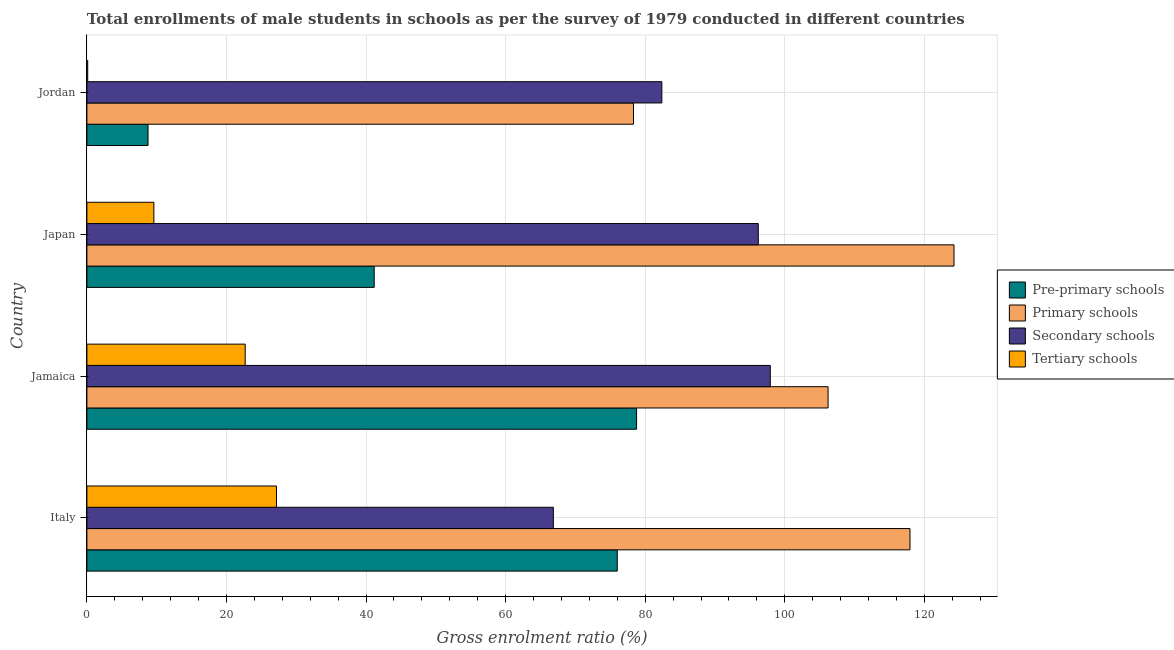How many groups of bars are there?
Your answer should be very brief. 4. Are the number of bars on each tick of the Y-axis equal?
Your response must be concise. Yes. How many bars are there on the 2nd tick from the bottom?
Give a very brief answer. 4. What is the label of the 1st group of bars from the top?
Your answer should be compact. Jordan. What is the gross enrolment ratio(male) in pre-primary schools in Jamaica?
Your answer should be compact. 78.76. Across all countries, what is the maximum gross enrolment ratio(male) in primary schools?
Keep it short and to the point. 124.24. Across all countries, what is the minimum gross enrolment ratio(male) in pre-primary schools?
Your answer should be very brief. 8.76. In which country was the gross enrolment ratio(male) in secondary schools minimum?
Your answer should be very brief. Italy. What is the total gross enrolment ratio(male) in tertiary schools in the graph?
Give a very brief answer. 59.56. What is the difference between the gross enrolment ratio(male) in tertiary schools in Japan and that in Jordan?
Provide a short and direct response. 9.48. What is the difference between the gross enrolment ratio(male) in pre-primary schools in Japan and the gross enrolment ratio(male) in primary schools in Italy?
Offer a terse response. -76.77. What is the average gross enrolment ratio(male) in primary schools per country?
Keep it short and to the point. 106.67. What is the difference between the gross enrolment ratio(male) in secondary schools and gross enrolment ratio(male) in primary schools in Jamaica?
Your answer should be very brief. -8.28. In how many countries, is the gross enrolment ratio(male) in primary schools greater than 48 %?
Provide a short and direct response. 4. What is the ratio of the gross enrolment ratio(male) in primary schools in Italy to that in Jamaica?
Your answer should be compact. 1.11. Is the difference between the gross enrolment ratio(male) in tertiary schools in Italy and Jordan greater than the difference between the gross enrolment ratio(male) in primary schools in Italy and Jordan?
Ensure brevity in your answer.  No. What is the difference between the highest and the second highest gross enrolment ratio(male) in tertiary schools?
Make the answer very short. 4.49. What is the difference between the highest and the lowest gross enrolment ratio(male) in secondary schools?
Give a very brief answer. 31.08. What does the 1st bar from the top in Jamaica represents?
Provide a short and direct response. Tertiary schools. What does the 3rd bar from the bottom in Jamaica represents?
Your answer should be very brief. Secondary schools. Is it the case that in every country, the sum of the gross enrolment ratio(male) in pre-primary schools and gross enrolment ratio(male) in primary schools is greater than the gross enrolment ratio(male) in secondary schools?
Give a very brief answer. Yes. How many countries are there in the graph?
Offer a very short reply. 4. Are the values on the major ticks of X-axis written in scientific E-notation?
Make the answer very short. No. Where does the legend appear in the graph?
Give a very brief answer. Center right. How are the legend labels stacked?
Provide a short and direct response. Vertical. What is the title of the graph?
Your answer should be very brief. Total enrollments of male students in schools as per the survey of 1979 conducted in different countries. Does "Belgium" appear as one of the legend labels in the graph?
Keep it short and to the point. No. What is the label or title of the X-axis?
Make the answer very short. Gross enrolment ratio (%). What is the Gross enrolment ratio (%) in Pre-primary schools in Italy?
Your answer should be very brief. 75.99. What is the Gross enrolment ratio (%) in Primary schools in Italy?
Make the answer very short. 117.93. What is the Gross enrolment ratio (%) of Secondary schools in Italy?
Keep it short and to the point. 66.84. What is the Gross enrolment ratio (%) in Tertiary schools in Italy?
Offer a very short reply. 27.17. What is the Gross enrolment ratio (%) in Pre-primary schools in Jamaica?
Offer a terse response. 78.76. What is the Gross enrolment ratio (%) in Primary schools in Jamaica?
Your answer should be very brief. 106.2. What is the Gross enrolment ratio (%) of Secondary schools in Jamaica?
Offer a very short reply. 97.92. What is the Gross enrolment ratio (%) in Tertiary schools in Jamaica?
Your response must be concise. 22.68. What is the Gross enrolment ratio (%) in Pre-primary schools in Japan?
Provide a short and direct response. 41.17. What is the Gross enrolment ratio (%) of Primary schools in Japan?
Ensure brevity in your answer.  124.24. What is the Gross enrolment ratio (%) in Secondary schools in Japan?
Provide a short and direct response. 96.2. What is the Gross enrolment ratio (%) of Tertiary schools in Japan?
Provide a succinct answer. 9.59. What is the Gross enrolment ratio (%) of Pre-primary schools in Jordan?
Your response must be concise. 8.76. What is the Gross enrolment ratio (%) in Primary schools in Jordan?
Give a very brief answer. 78.32. What is the Gross enrolment ratio (%) of Secondary schools in Jordan?
Offer a very short reply. 82.38. What is the Gross enrolment ratio (%) of Tertiary schools in Jordan?
Give a very brief answer. 0.12. Across all countries, what is the maximum Gross enrolment ratio (%) in Pre-primary schools?
Give a very brief answer. 78.76. Across all countries, what is the maximum Gross enrolment ratio (%) of Primary schools?
Provide a short and direct response. 124.24. Across all countries, what is the maximum Gross enrolment ratio (%) in Secondary schools?
Offer a very short reply. 97.92. Across all countries, what is the maximum Gross enrolment ratio (%) of Tertiary schools?
Your answer should be compact. 27.17. Across all countries, what is the minimum Gross enrolment ratio (%) of Pre-primary schools?
Keep it short and to the point. 8.76. Across all countries, what is the minimum Gross enrolment ratio (%) of Primary schools?
Keep it short and to the point. 78.32. Across all countries, what is the minimum Gross enrolment ratio (%) in Secondary schools?
Keep it short and to the point. 66.84. Across all countries, what is the minimum Gross enrolment ratio (%) of Tertiary schools?
Make the answer very short. 0.12. What is the total Gross enrolment ratio (%) of Pre-primary schools in the graph?
Your response must be concise. 204.68. What is the total Gross enrolment ratio (%) in Primary schools in the graph?
Provide a short and direct response. 426.69. What is the total Gross enrolment ratio (%) of Secondary schools in the graph?
Provide a succinct answer. 343.34. What is the total Gross enrolment ratio (%) of Tertiary schools in the graph?
Provide a succinct answer. 59.56. What is the difference between the Gross enrolment ratio (%) of Pre-primary schools in Italy and that in Jamaica?
Provide a short and direct response. -2.77. What is the difference between the Gross enrolment ratio (%) in Primary schools in Italy and that in Jamaica?
Provide a short and direct response. 11.74. What is the difference between the Gross enrolment ratio (%) of Secondary schools in Italy and that in Jamaica?
Provide a succinct answer. -31.08. What is the difference between the Gross enrolment ratio (%) in Tertiary schools in Italy and that in Jamaica?
Your response must be concise. 4.49. What is the difference between the Gross enrolment ratio (%) in Pre-primary schools in Italy and that in Japan?
Keep it short and to the point. 34.83. What is the difference between the Gross enrolment ratio (%) in Primary schools in Italy and that in Japan?
Your response must be concise. -6.31. What is the difference between the Gross enrolment ratio (%) of Secondary schools in Italy and that in Japan?
Your answer should be very brief. -29.36. What is the difference between the Gross enrolment ratio (%) in Tertiary schools in Italy and that in Japan?
Offer a very short reply. 17.57. What is the difference between the Gross enrolment ratio (%) of Pre-primary schools in Italy and that in Jordan?
Your answer should be very brief. 67.23. What is the difference between the Gross enrolment ratio (%) of Primary schools in Italy and that in Jordan?
Ensure brevity in your answer.  39.62. What is the difference between the Gross enrolment ratio (%) in Secondary schools in Italy and that in Jordan?
Provide a succinct answer. -15.55. What is the difference between the Gross enrolment ratio (%) in Tertiary schools in Italy and that in Jordan?
Keep it short and to the point. 27.05. What is the difference between the Gross enrolment ratio (%) of Pre-primary schools in Jamaica and that in Japan?
Your response must be concise. 37.59. What is the difference between the Gross enrolment ratio (%) in Primary schools in Jamaica and that in Japan?
Your answer should be very brief. -18.04. What is the difference between the Gross enrolment ratio (%) in Secondary schools in Jamaica and that in Japan?
Your answer should be very brief. 1.72. What is the difference between the Gross enrolment ratio (%) of Tertiary schools in Jamaica and that in Japan?
Make the answer very short. 13.09. What is the difference between the Gross enrolment ratio (%) of Pre-primary schools in Jamaica and that in Jordan?
Offer a terse response. 70. What is the difference between the Gross enrolment ratio (%) in Primary schools in Jamaica and that in Jordan?
Make the answer very short. 27.88. What is the difference between the Gross enrolment ratio (%) in Secondary schools in Jamaica and that in Jordan?
Your answer should be compact. 15.54. What is the difference between the Gross enrolment ratio (%) of Tertiary schools in Jamaica and that in Jordan?
Offer a very short reply. 22.57. What is the difference between the Gross enrolment ratio (%) in Pre-primary schools in Japan and that in Jordan?
Ensure brevity in your answer.  32.41. What is the difference between the Gross enrolment ratio (%) in Primary schools in Japan and that in Jordan?
Ensure brevity in your answer.  45.92. What is the difference between the Gross enrolment ratio (%) of Secondary schools in Japan and that in Jordan?
Make the answer very short. 13.82. What is the difference between the Gross enrolment ratio (%) of Tertiary schools in Japan and that in Jordan?
Keep it short and to the point. 9.48. What is the difference between the Gross enrolment ratio (%) of Pre-primary schools in Italy and the Gross enrolment ratio (%) of Primary schools in Jamaica?
Ensure brevity in your answer.  -30.2. What is the difference between the Gross enrolment ratio (%) in Pre-primary schools in Italy and the Gross enrolment ratio (%) in Secondary schools in Jamaica?
Offer a terse response. -21.92. What is the difference between the Gross enrolment ratio (%) of Pre-primary schools in Italy and the Gross enrolment ratio (%) of Tertiary schools in Jamaica?
Your answer should be very brief. 53.31. What is the difference between the Gross enrolment ratio (%) of Primary schools in Italy and the Gross enrolment ratio (%) of Secondary schools in Jamaica?
Offer a terse response. 20.02. What is the difference between the Gross enrolment ratio (%) in Primary schools in Italy and the Gross enrolment ratio (%) in Tertiary schools in Jamaica?
Your answer should be compact. 95.25. What is the difference between the Gross enrolment ratio (%) of Secondary schools in Italy and the Gross enrolment ratio (%) of Tertiary schools in Jamaica?
Provide a short and direct response. 44.15. What is the difference between the Gross enrolment ratio (%) in Pre-primary schools in Italy and the Gross enrolment ratio (%) in Primary schools in Japan?
Make the answer very short. -48.25. What is the difference between the Gross enrolment ratio (%) of Pre-primary schools in Italy and the Gross enrolment ratio (%) of Secondary schools in Japan?
Offer a very short reply. -20.21. What is the difference between the Gross enrolment ratio (%) of Pre-primary schools in Italy and the Gross enrolment ratio (%) of Tertiary schools in Japan?
Give a very brief answer. 66.4. What is the difference between the Gross enrolment ratio (%) of Primary schools in Italy and the Gross enrolment ratio (%) of Secondary schools in Japan?
Provide a short and direct response. 21.73. What is the difference between the Gross enrolment ratio (%) of Primary schools in Italy and the Gross enrolment ratio (%) of Tertiary schools in Japan?
Provide a succinct answer. 108.34. What is the difference between the Gross enrolment ratio (%) in Secondary schools in Italy and the Gross enrolment ratio (%) in Tertiary schools in Japan?
Ensure brevity in your answer.  57.24. What is the difference between the Gross enrolment ratio (%) of Pre-primary schools in Italy and the Gross enrolment ratio (%) of Primary schools in Jordan?
Make the answer very short. -2.32. What is the difference between the Gross enrolment ratio (%) in Pre-primary schools in Italy and the Gross enrolment ratio (%) in Secondary schools in Jordan?
Your answer should be compact. -6.39. What is the difference between the Gross enrolment ratio (%) in Pre-primary schools in Italy and the Gross enrolment ratio (%) in Tertiary schools in Jordan?
Provide a succinct answer. 75.88. What is the difference between the Gross enrolment ratio (%) of Primary schools in Italy and the Gross enrolment ratio (%) of Secondary schools in Jordan?
Make the answer very short. 35.55. What is the difference between the Gross enrolment ratio (%) of Primary schools in Italy and the Gross enrolment ratio (%) of Tertiary schools in Jordan?
Give a very brief answer. 117.82. What is the difference between the Gross enrolment ratio (%) of Secondary schools in Italy and the Gross enrolment ratio (%) of Tertiary schools in Jordan?
Offer a terse response. 66.72. What is the difference between the Gross enrolment ratio (%) of Pre-primary schools in Jamaica and the Gross enrolment ratio (%) of Primary schools in Japan?
Ensure brevity in your answer.  -45.48. What is the difference between the Gross enrolment ratio (%) of Pre-primary schools in Jamaica and the Gross enrolment ratio (%) of Secondary schools in Japan?
Your response must be concise. -17.44. What is the difference between the Gross enrolment ratio (%) of Pre-primary schools in Jamaica and the Gross enrolment ratio (%) of Tertiary schools in Japan?
Keep it short and to the point. 69.17. What is the difference between the Gross enrolment ratio (%) in Primary schools in Jamaica and the Gross enrolment ratio (%) in Secondary schools in Japan?
Keep it short and to the point. 10. What is the difference between the Gross enrolment ratio (%) in Primary schools in Jamaica and the Gross enrolment ratio (%) in Tertiary schools in Japan?
Offer a very short reply. 96.6. What is the difference between the Gross enrolment ratio (%) in Secondary schools in Jamaica and the Gross enrolment ratio (%) in Tertiary schools in Japan?
Your answer should be compact. 88.32. What is the difference between the Gross enrolment ratio (%) of Pre-primary schools in Jamaica and the Gross enrolment ratio (%) of Primary schools in Jordan?
Your answer should be compact. 0.44. What is the difference between the Gross enrolment ratio (%) of Pre-primary schools in Jamaica and the Gross enrolment ratio (%) of Secondary schools in Jordan?
Keep it short and to the point. -3.62. What is the difference between the Gross enrolment ratio (%) in Pre-primary schools in Jamaica and the Gross enrolment ratio (%) in Tertiary schools in Jordan?
Make the answer very short. 78.64. What is the difference between the Gross enrolment ratio (%) in Primary schools in Jamaica and the Gross enrolment ratio (%) in Secondary schools in Jordan?
Your answer should be compact. 23.82. What is the difference between the Gross enrolment ratio (%) in Primary schools in Jamaica and the Gross enrolment ratio (%) in Tertiary schools in Jordan?
Keep it short and to the point. 106.08. What is the difference between the Gross enrolment ratio (%) in Secondary schools in Jamaica and the Gross enrolment ratio (%) in Tertiary schools in Jordan?
Ensure brevity in your answer.  97.8. What is the difference between the Gross enrolment ratio (%) in Pre-primary schools in Japan and the Gross enrolment ratio (%) in Primary schools in Jordan?
Make the answer very short. -37.15. What is the difference between the Gross enrolment ratio (%) in Pre-primary schools in Japan and the Gross enrolment ratio (%) in Secondary schools in Jordan?
Make the answer very short. -41.22. What is the difference between the Gross enrolment ratio (%) in Pre-primary schools in Japan and the Gross enrolment ratio (%) in Tertiary schools in Jordan?
Make the answer very short. 41.05. What is the difference between the Gross enrolment ratio (%) in Primary schools in Japan and the Gross enrolment ratio (%) in Secondary schools in Jordan?
Offer a terse response. 41.86. What is the difference between the Gross enrolment ratio (%) of Primary schools in Japan and the Gross enrolment ratio (%) of Tertiary schools in Jordan?
Ensure brevity in your answer.  124.13. What is the difference between the Gross enrolment ratio (%) in Secondary schools in Japan and the Gross enrolment ratio (%) in Tertiary schools in Jordan?
Give a very brief answer. 96.08. What is the average Gross enrolment ratio (%) of Pre-primary schools per country?
Make the answer very short. 51.17. What is the average Gross enrolment ratio (%) in Primary schools per country?
Your answer should be very brief. 106.67. What is the average Gross enrolment ratio (%) in Secondary schools per country?
Keep it short and to the point. 85.83. What is the average Gross enrolment ratio (%) of Tertiary schools per country?
Offer a very short reply. 14.89. What is the difference between the Gross enrolment ratio (%) of Pre-primary schools and Gross enrolment ratio (%) of Primary schools in Italy?
Offer a terse response. -41.94. What is the difference between the Gross enrolment ratio (%) of Pre-primary schools and Gross enrolment ratio (%) of Secondary schools in Italy?
Provide a short and direct response. 9.16. What is the difference between the Gross enrolment ratio (%) in Pre-primary schools and Gross enrolment ratio (%) in Tertiary schools in Italy?
Ensure brevity in your answer.  48.83. What is the difference between the Gross enrolment ratio (%) in Primary schools and Gross enrolment ratio (%) in Secondary schools in Italy?
Your answer should be very brief. 51.1. What is the difference between the Gross enrolment ratio (%) of Primary schools and Gross enrolment ratio (%) of Tertiary schools in Italy?
Provide a short and direct response. 90.77. What is the difference between the Gross enrolment ratio (%) in Secondary schools and Gross enrolment ratio (%) in Tertiary schools in Italy?
Provide a succinct answer. 39.67. What is the difference between the Gross enrolment ratio (%) of Pre-primary schools and Gross enrolment ratio (%) of Primary schools in Jamaica?
Make the answer very short. -27.44. What is the difference between the Gross enrolment ratio (%) of Pre-primary schools and Gross enrolment ratio (%) of Secondary schools in Jamaica?
Your response must be concise. -19.16. What is the difference between the Gross enrolment ratio (%) of Pre-primary schools and Gross enrolment ratio (%) of Tertiary schools in Jamaica?
Offer a terse response. 56.08. What is the difference between the Gross enrolment ratio (%) of Primary schools and Gross enrolment ratio (%) of Secondary schools in Jamaica?
Give a very brief answer. 8.28. What is the difference between the Gross enrolment ratio (%) in Primary schools and Gross enrolment ratio (%) in Tertiary schools in Jamaica?
Provide a succinct answer. 83.52. What is the difference between the Gross enrolment ratio (%) of Secondary schools and Gross enrolment ratio (%) of Tertiary schools in Jamaica?
Provide a short and direct response. 75.24. What is the difference between the Gross enrolment ratio (%) in Pre-primary schools and Gross enrolment ratio (%) in Primary schools in Japan?
Ensure brevity in your answer.  -83.08. What is the difference between the Gross enrolment ratio (%) in Pre-primary schools and Gross enrolment ratio (%) in Secondary schools in Japan?
Your answer should be very brief. -55.03. What is the difference between the Gross enrolment ratio (%) in Pre-primary schools and Gross enrolment ratio (%) in Tertiary schools in Japan?
Ensure brevity in your answer.  31.57. What is the difference between the Gross enrolment ratio (%) of Primary schools and Gross enrolment ratio (%) of Secondary schools in Japan?
Provide a short and direct response. 28.04. What is the difference between the Gross enrolment ratio (%) of Primary schools and Gross enrolment ratio (%) of Tertiary schools in Japan?
Provide a short and direct response. 114.65. What is the difference between the Gross enrolment ratio (%) of Secondary schools and Gross enrolment ratio (%) of Tertiary schools in Japan?
Offer a terse response. 86.61. What is the difference between the Gross enrolment ratio (%) in Pre-primary schools and Gross enrolment ratio (%) in Primary schools in Jordan?
Offer a terse response. -69.56. What is the difference between the Gross enrolment ratio (%) of Pre-primary schools and Gross enrolment ratio (%) of Secondary schools in Jordan?
Offer a terse response. -73.62. What is the difference between the Gross enrolment ratio (%) of Pre-primary schools and Gross enrolment ratio (%) of Tertiary schools in Jordan?
Keep it short and to the point. 8.64. What is the difference between the Gross enrolment ratio (%) of Primary schools and Gross enrolment ratio (%) of Secondary schools in Jordan?
Offer a terse response. -4.06. What is the difference between the Gross enrolment ratio (%) of Primary schools and Gross enrolment ratio (%) of Tertiary schools in Jordan?
Keep it short and to the point. 78.2. What is the difference between the Gross enrolment ratio (%) of Secondary schools and Gross enrolment ratio (%) of Tertiary schools in Jordan?
Keep it short and to the point. 82.27. What is the ratio of the Gross enrolment ratio (%) in Pre-primary schools in Italy to that in Jamaica?
Your answer should be compact. 0.96. What is the ratio of the Gross enrolment ratio (%) in Primary schools in Italy to that in Jamaica?
Your answer should be compact. 1.11. What is the ratio of the Gross enrolment ratio (%) in Secondary schools in Italy to that in Jamaica?
Ensure brevity in your answer.  0.68. What is the ratio of the Gross enrolment ratio (%) in Tertiary schools in Italy to that in Jamaica?
Offer a very short reply. 1.2. What is the ratio of the Gross enrolment ratio (%) of Pre-primary schools in Italy to that in Japan?
Make the answer very short. 1.85. What is the ratio of the Gross enrolment ratio (%) in Primary schools in Italy to that in Japan?
Keep it short and to the point. 0.95. What is the ratio of the Gross enrolment ratio (%) of Secondary schools in Italy to that in Japan?
Keep it short and to the point. 0.69. What is the ratio of the Gross enrolment ratio (%) of Tertiary schools in Italy to that in Japan?
Make the answer very short. 2.83. What is the ratio of the Gross enrolment ratio (%) in Pre-primary schools in Italy to that in Jordan?
Give a very brief answer. 8.68. What is the ratio of the Gross enrolment ratio (%) in Primary schools in Italy to that in Jordan?
Your answer should be very brief. 1.51. What is the ratio of the Gross enrolment ratio (%) of Secondary schools in Italy to that in Jordan?
Your answer should be compact. 0.81. What is the ratio of the Gross enrolment ratio (%) in Tertiary schools in Italy to that in Jordan?
Your response must be concise. 233.7. What is the ratio of the Gross enrolment ratio (%) of Pre-primary schools in Jamaica to that in Japan?
Your answer should be compact. 1.91. What is the ratio of the Gross enrolment ratio (%) of Primary schools in Jamaica to that in Japan?
Provide a succinct answer. 0.85. What is the ratio of the Gross enrolment ratio (%) in Secondary schools in Jamaica to that in Japan?
Provide a succinct answer. 1.02. What is the ratio of the Gross enrolment ratio (%) of Tertiary schools in Jamaica to that in Japan?
Your response must be concise. 2.36. What is the ratio of the Gross enrolment ratio (%) of Pre-primary schools in Jamaica to that in Jordan?
Give a very brief answer. 8.99. What is the ratio of the Gross enrolment ratio (%) of Primary schools in Jamaica to that in Jordan?
Your answer should be compact. 1.36. What is the ratio of the Gross enrolment ratio (%) of Secondary schools in Jamaica to that in Jordan?
Keep it short and to the point. 1.19. What is the ratio of the Gross enrolment ratio (%) in Tertiary schools in Jamaica to that in Jordan?
Offer a terse response. 195.11. What is the ratio of the Gross enrolment ratio (%) in Pre-primary schools in Japan to that in Jordan?
Your response must be concise. 4.7. What is the ratio of the Gross enrolment ratio (%) in Primary schools in Japan to that in Jordan?
Your response must be concise. 1.59. What is the ratio of the Gross enrolment ratio (%) of Secondary schools in Japan to that in Jordan?
Provide a short and direct response. 1.17. What is the ratio of the Gross enrolment ratio (%) in Tertiary schools in Japan to that in Jordan?
Your answer should be very brief. 82.54. What is the difference between the highest and the second highest Gross enrolment ratio (%) in Pre-primary schools?
Provide a succinct answer. 2.77. What is the difference between the highest and the second highest Gross enrolment ratio (%) in Primary schools?
Your answer should be very brief. 6.31. What is the difference between the highest and the second highest Gross enrolment ratio (%) of Secondary schools?
Your answer should be compact. 1.72. What is the difference between the highest and the second highest Gross enrolment ratio (%) of Tertiary schools?
Your answer should be compact. 4.49. What is the difference between the highest and the lowest Gross enrolment ratio (%) in Pre-primary schools?
Make the answer very short. 70. What is the difference between the highest and the lowest Gross enrolment ratio (%) of Primary schools?
Offer a very short reply. 45.92. What is the difference between the highest and the lowest Gross enrolment ratio (%) of Secondary schools?
Provide a succinct answer. 31.08. What is the difference between the highest and the lowest Gross enrolment ratio (%) of Tertiary schools?
Offer a very short reply. 27.05. 